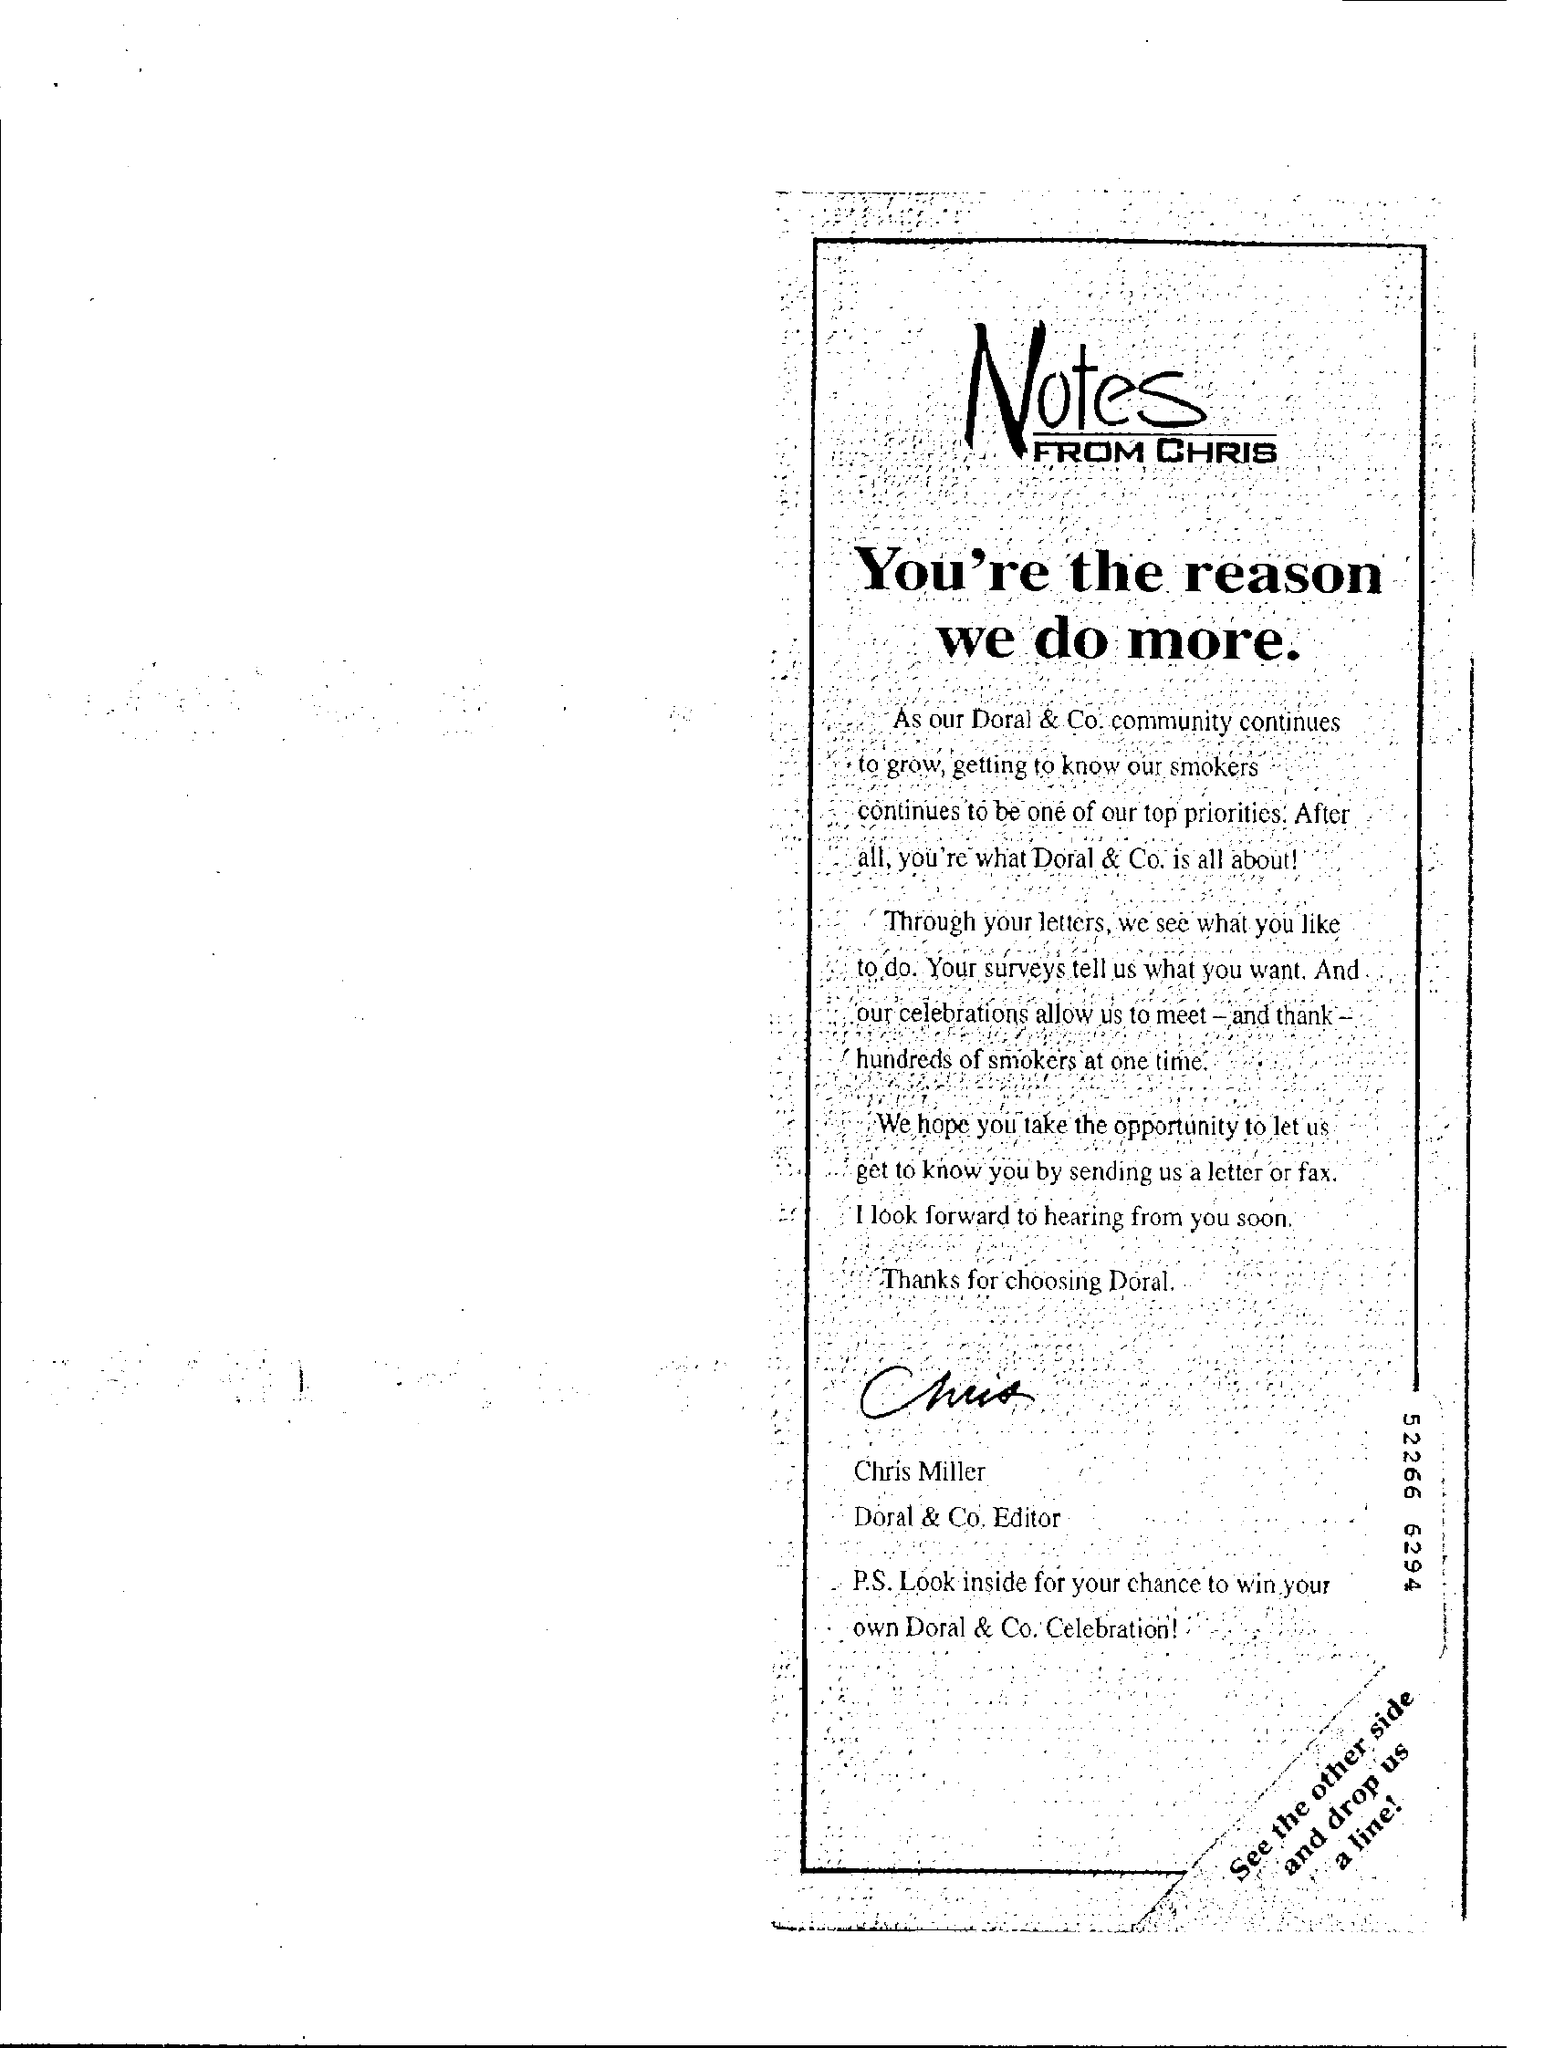Mention a couple of crucial points in this snapshot. The title of the document is Notes from Chris, and these are the notes he has taken. Chris Miller is the Doral & Co. Editor. 